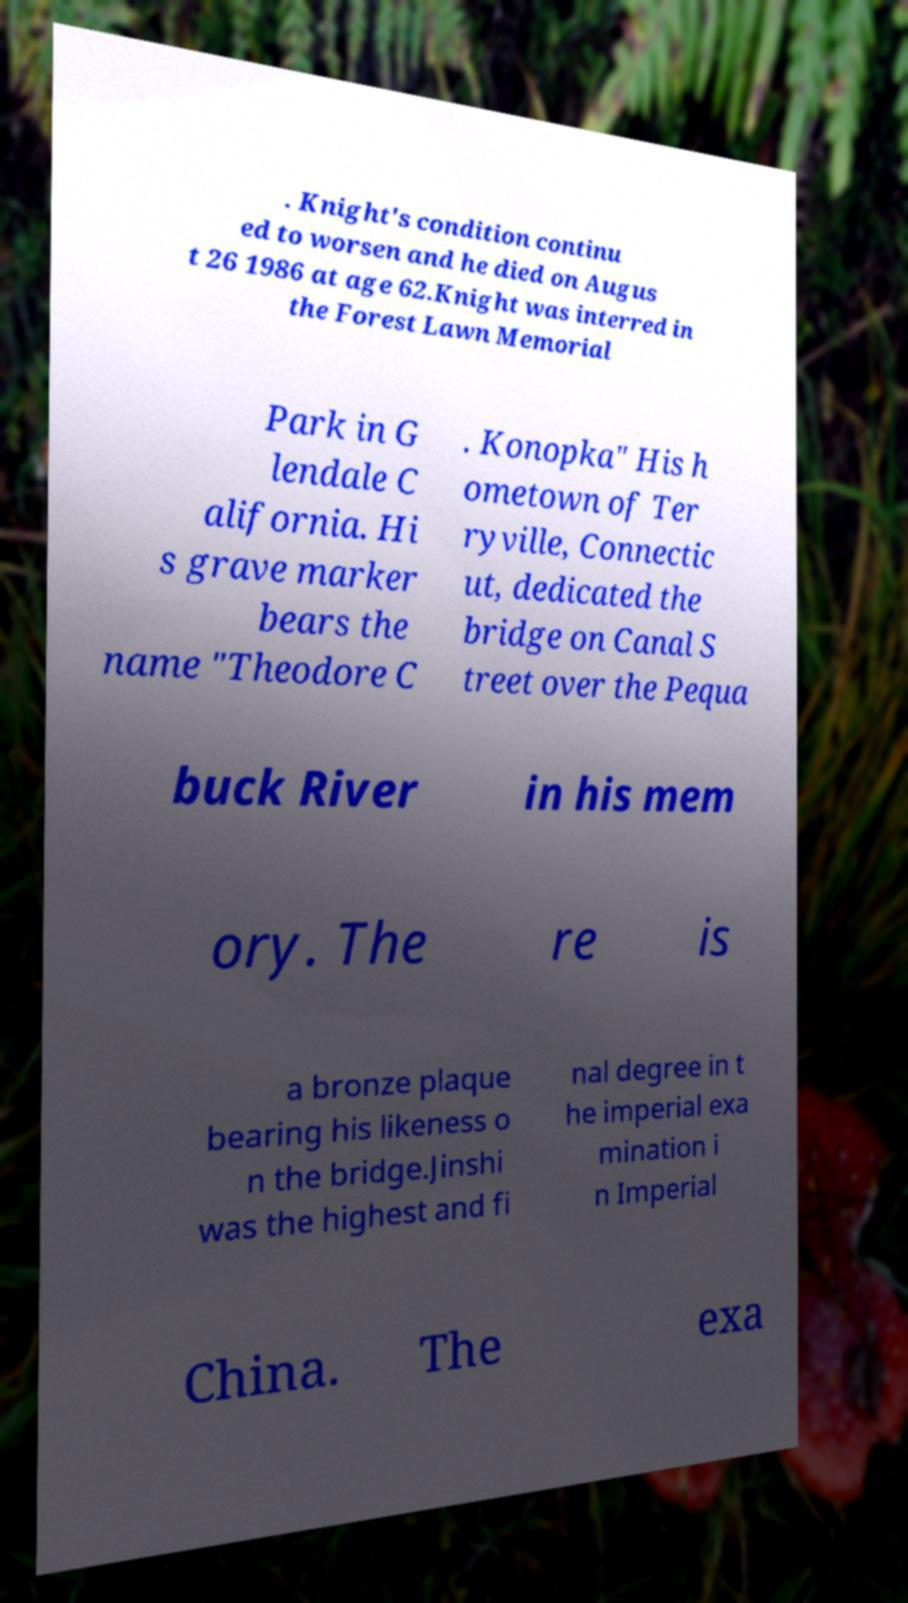Can you accurately transcribe the text from the provided image for me? . Knight's condition continu ed to worsen and he died on Augus t 26 1986 at age 62.Knight was interred in the Forest Lawn Memorial Park in G lendale C alifornia. Hi s grave marker bears the name "Theodore C . Konopka" His h ometown of Ter ryville, Connectic ut, dedicated the bridge on Canal S treet over the Pequa buck River in his mem ory. The re is a bronze plaque bearing his likeness o n the bridge.Jinshi was the highest and fi nal degree in t he imperial exa mination i n Imperial China. The exa 